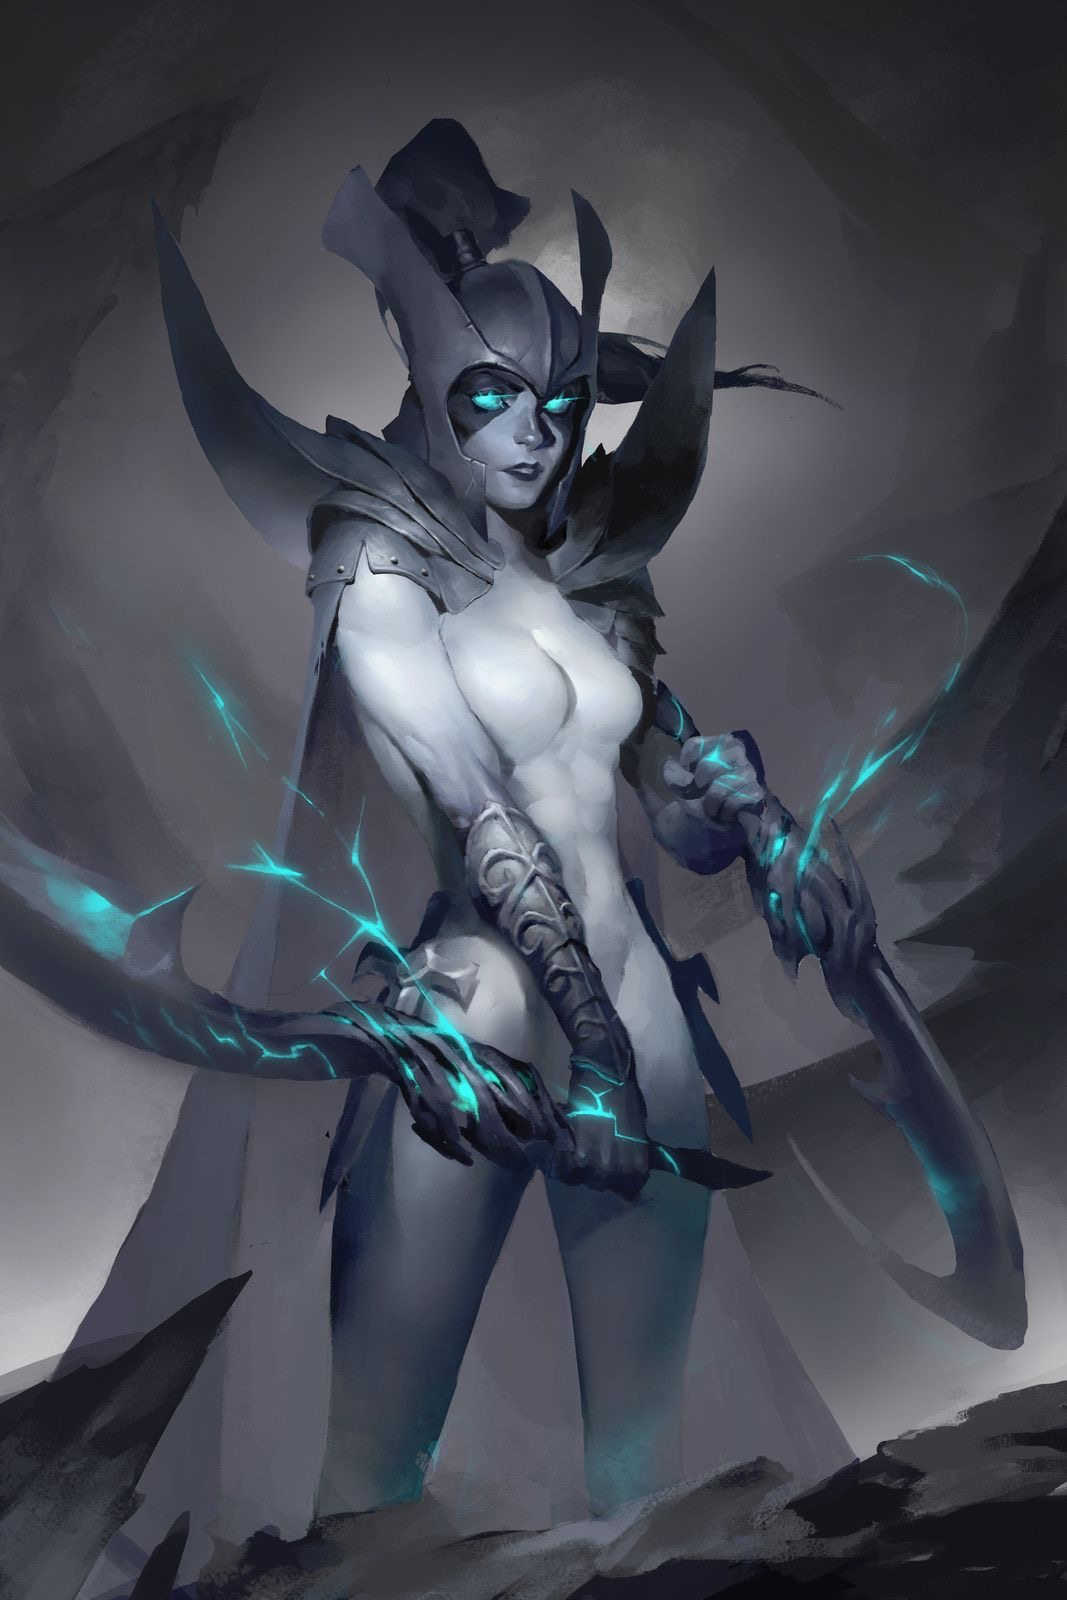analyze this image and its content in detail, mostly the style and figure in the image and what it’s doing. also give specific details about the figures skin, body parts or anything in the image that you can’t describe normally such as “realism, exquisite realistic, 35mm, realistic texture, 2D anime style, Promotional game Dark Fantasy 2D Digital Painting Illustration, Dark Fantasy 2D Digital Painting Illustration, Dark fantasy, 2D digital, illustration, Dark Fantasy anime manga 2D illustration, card game, painterly, copyrighted text, exquisite 2D illustration, anime manga illustration, 2d manga portrait, anime art, manga anime, manwha, female anime portrait, anime sketch art, sketch anime, anime sketch, male manga art, central figure is wearing jacket, brown hair, wet hair, short hair, long hair, female, male, very handsome anime male, handsome male sketch, pinterest anime, pinterest manga anime aesthetic, pinterest manga portrait art, pinterest inspired anime sketch, anything anime, anime manga panel, anime panel, rage anime illustration, bleach anime, sexy hot aesthetic male anime, big boobs, medium boobs, thick thighs, anime wallpaper, gigantic boobs, pinterest manga icons, manga icons, an exquisite digital painting, meticulously crafted, very exquisite, a striking, Young brown skin 18 year old male, the central figure is 18 years old and dark brown skin, dark skin 18 year old, the central figure is dark skin, the central figure is brown skin, young male rapper aesthetic, young 18 year old young man, young man, young woman, young eighteen or twenty year old woman, female rapper aesthetic, modern day female rapper aesthetic, long pink lace front hair, female central figure is wearing long lace front hair, extremely big booty, slim waiste with a gigantic booty, female central figure has modern day brazilian butt lift body, large silver chains, shinning large chain necklace, rapper large silver chains, chain accessories, diamond stud earrings, diamond studs, short dread haircut, short teen dread haircut, faded haircut, young man short dread haircut, central figure is wearing gucci, central figure is wearing versace, brown short dread haircut, central figure is wearing versace, central figure is wearing fendi, name brand clothing, extremely handsome face, slim muscular build, shirt off, no shirt at all, central figure has shirt off, gold grillz teeth, silver grillz teeth, extreme handsome face, extremely handsome, defined jawline, male rapper aesthetic, nike sweatshirt, white tank top, rolled up white shirt, modern day sagging pants, big crotch, jeans sagging, holding microphone”. and also here is an example prompt.
Ideogram Ai prompt:: “A whimsical and vibrant comic illustration featuring a charming tortoiseshell cat named "Mittens" exploring a magical mushroom forest. Mittens has large amber eyes filled with curiosity and joy. Her coat is a playful mix of orange, black, and brown, forming a beautiful mosaic pattern. She wears a small explorer's hat and a pink vest with numerous pockets, a magnifying glass in one paw and a brown backpack on her back. The forest is filled with colorful and giant mushrooms, with fairy lights twinkling around and small magical creatures hiding among the plants. Surrounding Mittens are bright stone paths and luminous flowers, adding a touch of fantasy and adventure to the scene. The image is full of details, capturing the essence of an enchanting and magical comic adventure., vibrant.” see how coherent it is with the prompt and you only have to use a few words. so what i want you to do is analyze the entire image EXTREMELY be as coherent as possible and don’t forget to use details from the list very above i provided as well. don’t forget the direction, height and size dynamic ratio of the central figure which could also help the ai image look more like the input image i gave you as well as what position the central figure is in the image mainly as well as the very exquisite details. also put in the output the words in the image and copyright name which will indicate and aid the ai more in the style of the image. be as strategic as possible with the details. here are some output examples
image::
output::A menacing, blue-skinned creature with glowing red eyes, large horns, and fiery tattoos on its body. It wields a massive, glowing sword that seems to be emanating energy. The creature is surrounded by a hazy, fiery atmosphere, with chains and other dark artifacts scattered around. In the background, there are silhouettes of mountains and a dramatic sky filled with clouds.
image::
output::A menacing, purple-hued creature with glowing red eyes, standing amidst a rocky terrain. The creature wields a staff with a skull at its top, emanating a purple aura. In its other hand, it conjures a swirling purple energy that forms a skull. The background depicts a dramatic sky with dark clouds, and scattered skulls can be seen on the ground. The creature's muscular physique and sharp claws suggest strength and aggression. The bottom right corner of the image has a watermark indicating it's from 'DEVIANTART' and credits the artist as 'Raphael Lacoste'.
image::
output::A menacing, skeletal creature with glowing red eyes, long flowing hair, and a tattered, red cloak adorned with golden runes. The creature is poised in a dramatic stance, with one hand pointing forward and the other holding a golden ring. In the background, there's a haunting, fog-covered landscape with ruins, bats flying around, and a looming castle or fortress. The overall atmosphere is eerie and foreboding, suggesting a dark fantasy or horror setting. 
see how everything flows on its own and goes straight to what the central figure and image looks like and adds the overall style at the end as well as the length of the output which is at least 73 words like this “A menacing, skeletal creature with glowing red eyes, long flowing hair, and a tattered, red cloak adorned with golden runes. The creature is poised in a dramatic stance, with one hand pointing forward and the other holding a golden ring. In the background, there's a haunting, fog-covered landscape with ruins, bats flying around, and a looming castle or fortress. The overall atmosphere is eerie and foreboding, suggesting a dark fantasy or horror setting.”, now you try. 

analyze this image and its content in detail, mostly the style and figure in the image and what it’s doing. also give specific details about the figures skin, body parts or anything in the image that you can’t describe normally such as “realism, exquisite realistic, 35mm, realistic texture, 2D anime style, Promotional game Dark Fantasy 2D Digital Painting Illustration, Dark Fantasy 2D Digital Painting Illustration, Dark fantasy, 2D digital, illustration, Dark Fantasy anime manga 2D illustration, WaterColor illustration, watercolor, card game, painterly, copyrighted text, exquisite 2D illustration, anime manga illustration, 2d manga portrait, anime art, manga anime, manwha, female anime portrait, anime sketch art, sketch anime, anime sketch, male manga art, central figure is wearing jacket, brown hair, wet hair, short hair, long hair, female, male, very handsome anime male, handsome male sketch, pinterest anime, pinterest manga anime aesthetic, pinterest manga portrait art, pinterest inspired anime sketch, anything anime, anime manga panel, anime panel, rage anime illustration, bleach anime, sexy hot aesthetic male anime, big boobs, medium boobs, thick thighs, anime wallpaper, gigantic boobs, pinterest manga icons, manga icons, an exquisite digital painting, meticulously crafted, very exquisite, a striking, Young brown skin 18 year old male, the central figure is 18 years old and dark brown skin, dark skin 18 year old, the central figure is dark skin, the central figure is brown skin, young male rapper aesthetic, young 18 year old young man, young man, young woman, young eighteen or twenty year old woman, female rapper aesthetic, modern day female rapper aesthetic, long pink lace front hair, female central figure is wearing long lace front hair, extremely big booty, slim waiste with a gigantic booty, female central figure has modern day brazilian butt lift body, large silver chains, shinning large chain necklace, rapper large silver chains, chain accessories, diamond stud earrings, diamond studs, short dread haircut, short teen dread haircut, faded haircut, young man short dread haircut, central figure is wearing gucci, central figure is wearing versace, brown short dread haircut, central figure is wearing versace, central figure is wearing fendi, name brand clothing, extremely handsome face, slim muscular build, shirt off, no shirt at all, central figure has shirt off, gold grillz teeth, silver grillz teeth, extreme handsome face, extremely handsome, defined jawline, male rapper aesthetic, nike sweatshirt, white tank top, rolled up white shirt, modern day sagging pants, big crotch, jeans sagging, holding microphone”. and also here is an example prompt.
Ideogram Ai prompt:: “A whimsical and vibrant comic illustration featuring a charming tortoiseshell cat named "Mittens" exploring a magical mushroom forest. Mittens has large amber eyes filled with curiosity and joy. Her coat is a playful mix of orange, black, and brown, forming a beautiful mosaic pattern. She wears a small explorer's hat and a pink vest with numerous pockets, a magnifying glass in one paw and a brown backpack on her back. The forest is filled with colorful and giant mushrooms, with fairy lights twinkling around and small magical creatures hiding among the plants. Surrounding Mittens are bright stone paths and luminous flowers, adding a touch of fantasy and adventure to the scene. The image is full of details, capturing the essence of an enchanting and magical comic adventure., vibrant.” see how coherent it is with the prompt and you only have to use a few words. so what i want you to do is analyze the entire image EXTREMELY be as coherent as possible and don’t forget to use details from the list very above i provided as well. don’t forget the direction, height and size dynamic ratio of the central figure which could also help the ai image look more like the input image i gave you as well as what position the central figure is in the image mainly as well as the very exquisite details. also put in the output the words in the image and copyright name which will indicate and aid the ai more in the style of the image. be as strategic as possible with the details. here are some output examples
image::
output::A menacing, blue-skinned creature with glowing red eyes, large horns, and fiery tattoos on its body. It wields a massive, glowing sword that seems to be emanating energy. The creature is surrounded by a hazy, fiery atmosphere, with chains and other dark artifacts scattered around. In the background, there are silhouettes of mountains and a dramatic sky filled with clouds.
image::
output::A menacing, purple-hued creature with glowing red eyes, standing amidst a rocky terrain. The creature wields a staff with a skull at its top, emanating a purple aura. In its other hand, it conjures a swirling purple energy that forms a skull. The background depicts a dramatic sky with dark clouds, and scattered skulls can be seen on the ground. The creature's muscular physique and sharp claws suggest strength and aggression. The bottom right corner of the image has a watermark indicating it's from 'DEVIANTART' and credits the artist as 'Raphael Lacoste'.
image::
output::A menacing, skeletal creature with glowing red eyes, long flowing hair, and a tattered, red cloak adorned with golden runes. The creature is poised in a dramatic stance, with one hand pointing forward and the other holding a golden ring. In the background, there's a haunting, fog-covered landscape with ruins, bats flying around, and a looming castle or fortress. The overall atmosphere is eerie and foreboding, suggesting a dark fantasy or horror setting. output::A menacing, armored female figure with glowing blue eyes, standing in a dynamic pose. She wears a dark, spiked helmet and pauldrons, and wields two large, glowing blue scythes. Her skin is pale and has a realistic texture, emphasizing her muscular build. The background is a dark, smoky environment, adding to the overall eerie and foreboding atmosphere. The image is a meticulously crafted dark fantasy 2D digital painting, with exquisite details and a striking composition. The bottom right corner has a watermark indicating it's from 'ARTSTATION' and credits the artist as 'Lorens'. 